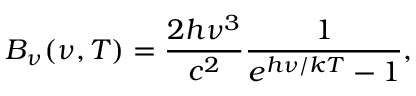<formula> <loc_0><loc_0><loc_500><loc_500>B _ { \nu } ( \nu , T ) = { \frac { 2 h \nu ^ { 3 } } { c ^ { 2 } } } { \frac { 1 } { e ^ { h \nu / k T } - 1 } } ,</formula> 